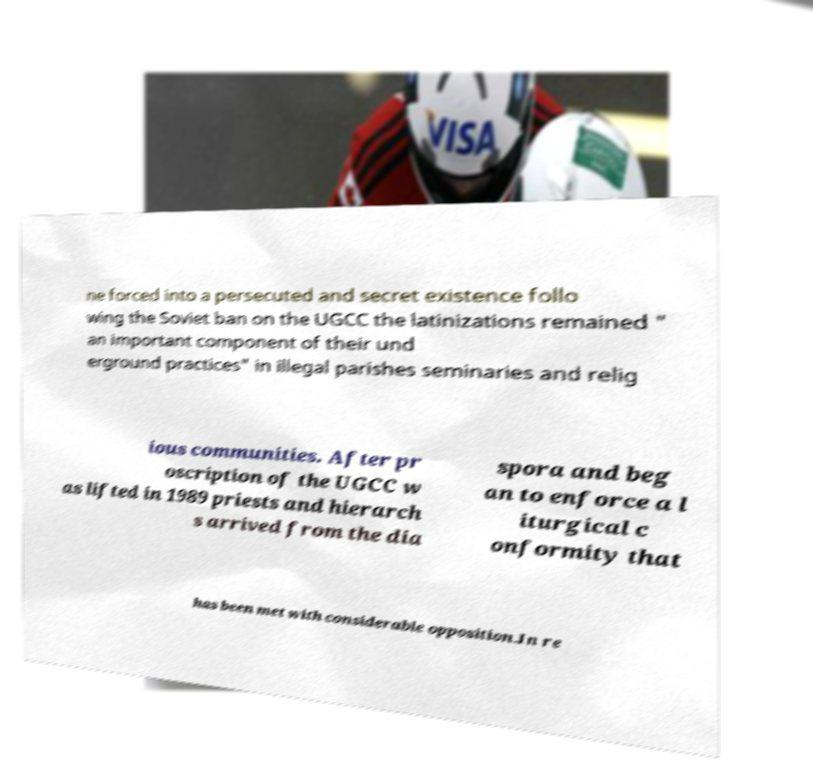I need the written content from this picture converted into text. Can you do that? ne forced into a persecuted and secret existence follo wing the Soviet ban on the UGCC the latinizations remained " an important component of their und erground practices" in illegal parishes seminaries and relig ious communities. After pr oscription of the UGCC w as lifted in 1989 priests and hierarch s arrived from the dia spora and beg an to enforce a l iturgical c onformity that has been met with considerable opposition.In re 